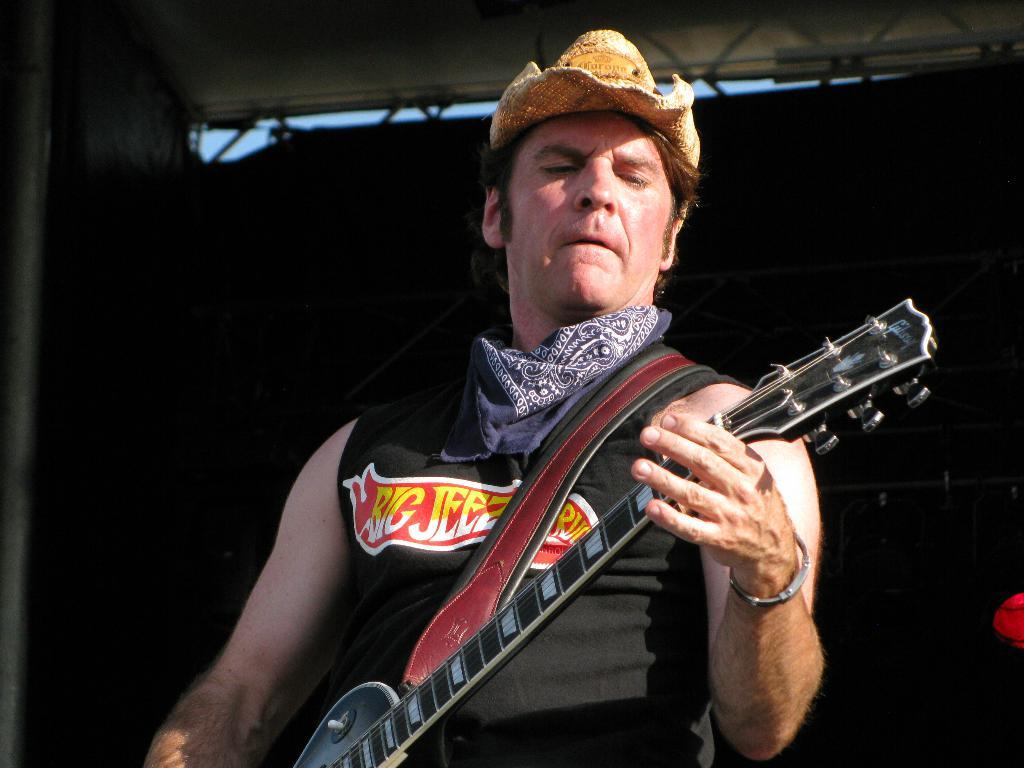What is the main subject of the image? There is a man in the image. What is the man doing in the image? The man is standing in the image. What object is the man holding in the image? The man is holding a guitar in his hands. What color is the crayon that the man is using in the image? There is no crayon present in the image; the man is holding a guitar. What type of ornament is hanging from the man's mouth in the image? There is no ornament hanging from the man's mouth in the image; he is holding a guitar. 